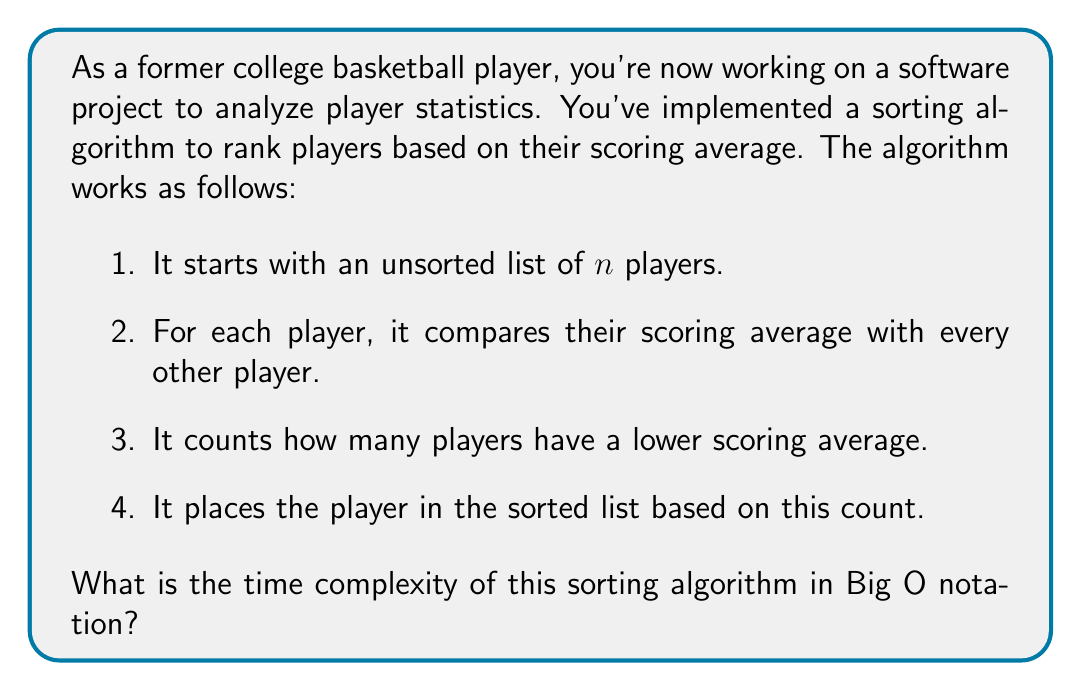Could you help me with this problem? Let's analyze this algorithm step by step:

1. The algorithm iterates through all $n$ players in the list. This gives us our outer loop, which runs $n$ times.

2. For each player, it compares with every other player. This is our inner loop, which also runs $n$ times for each iteration of the outer loop.

3. The comparison and counting operations inside the inner loop are constant time operations, O(1).

4. Placing the player in the sorted list based on the count can be considered a constant time operation if we assume we're using an array and can directly access the correct index.

The structure of the algorithm can be represented as:

```
for each player in n players:
    for each other player in n players:
        compare and count
    place player in sorted list
```

This nested loop structure gives us a time complexity of $O(n^2)$.

To be more precise:
- The outer loop runs $n$ times
- For each iteration of the outer loop, the inner loop runs $n$ times
- The operations inside the inner loop are constant time

So, the total number of operations is approximately $n * n * c$, where $c$ is some constant.

In Big O notation, we drop constants and lower-order terms, leaving us with $O(n^2)$.

This quadratic time complexity is characteristic of comparison-based sorting algorithms like Bubble Sort or Selection Sort. While simple to implement, these algorithms are generally not efficient for large datasets and are typically outperformed by more advanced algorithms like QuickSort or MergeSort for larger values of $n$.
Answer: $O(n^2)$ 